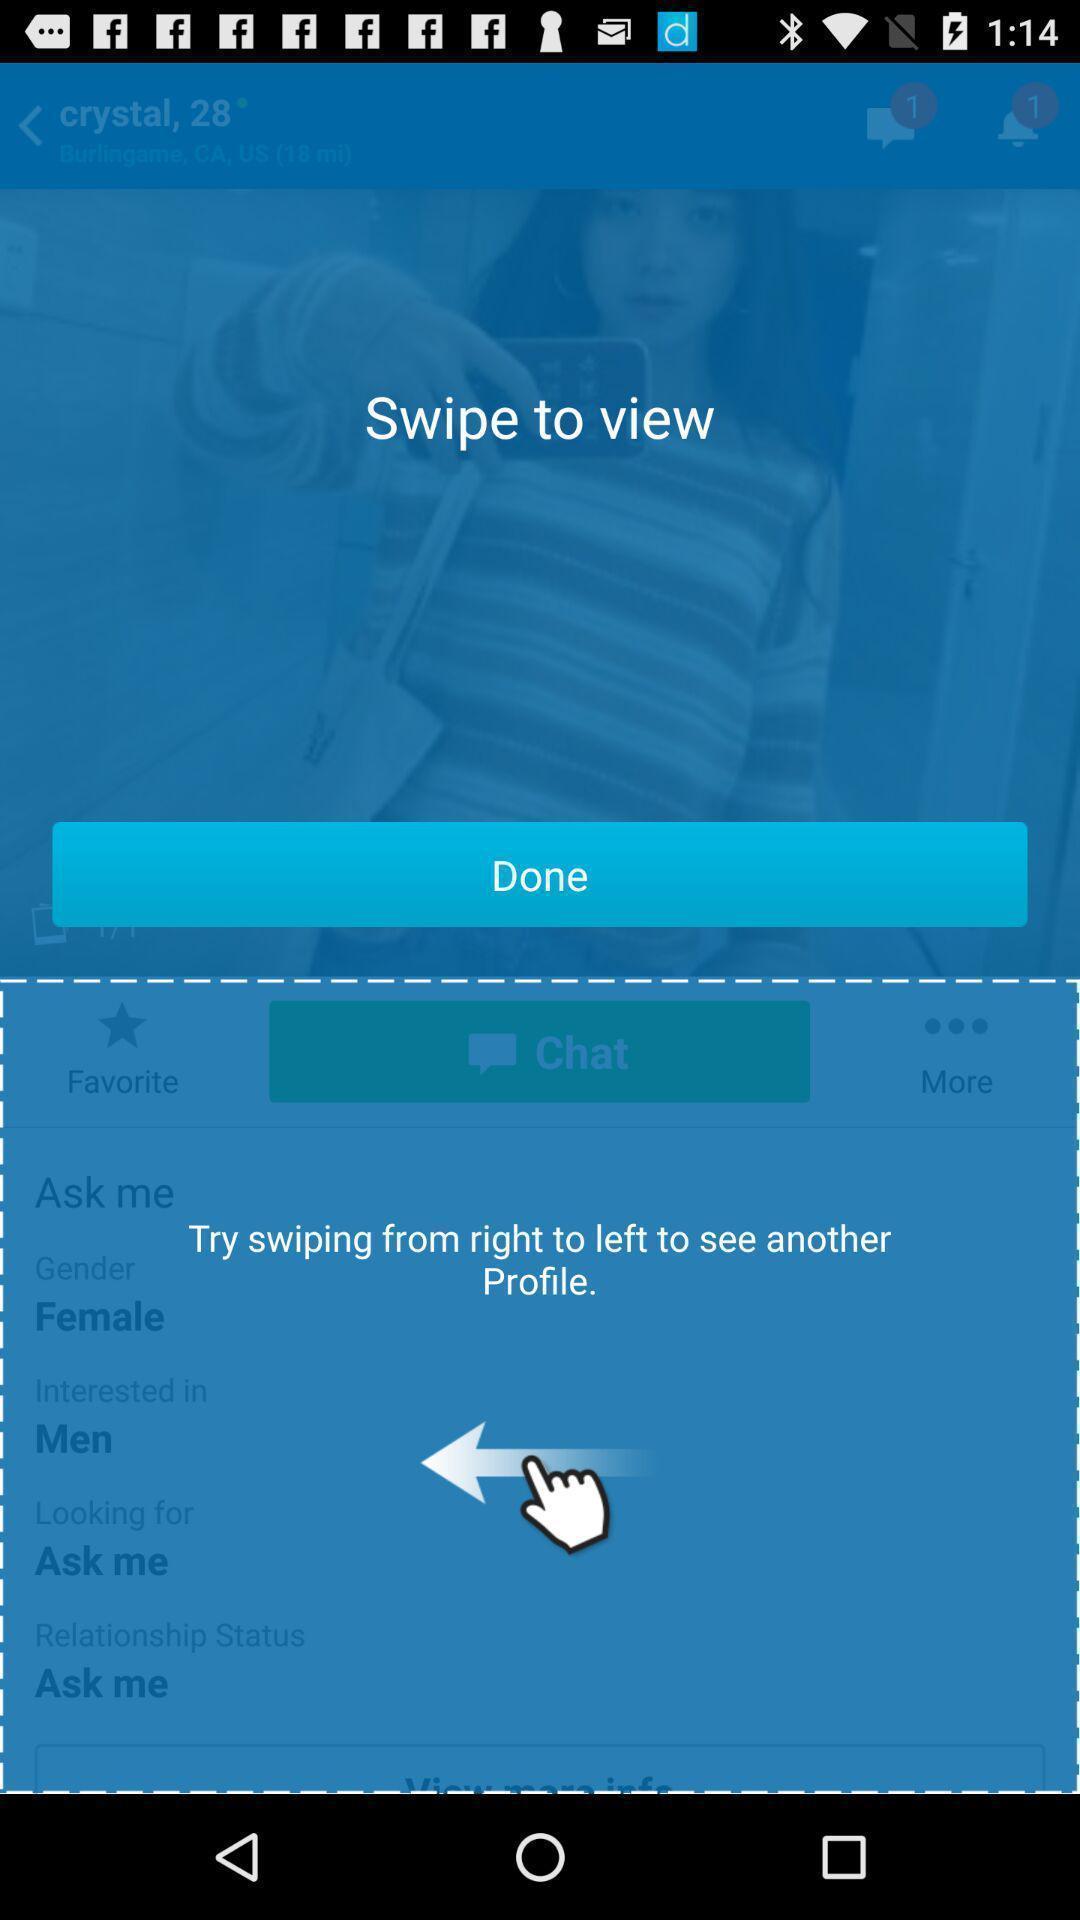Describe the visual elements of this screenshot. Page displaying instructions in a social app. 